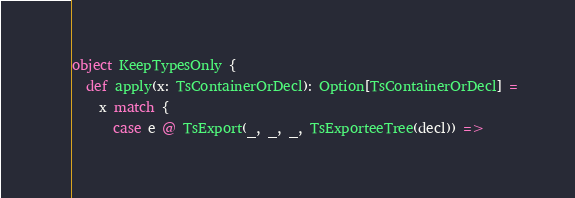<code> <loc_0><loc_0><loc_500><loc_500><_Scala_>
object KeepTypesOnly {
  def apply(x: TsContainerOrDecl): Option[TsContainerOrDecl] =
    x match {
      case e @ TsExport(_, _, _, TsExporteeTree(decl)) =></code> 